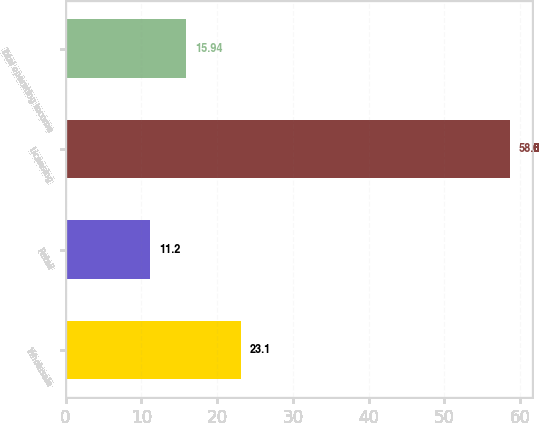Convert chart to OTSL. <chart><loc_0><loc_0><loc_500><loc_500><bar_chart><fcel>Wholesale<fcel>Retail<fcel>Licensing<fcel>Total operating income<nl><fcel>23.1<fcel>11.2<fcel>58.6<fcel>15.94<nl></chart> 